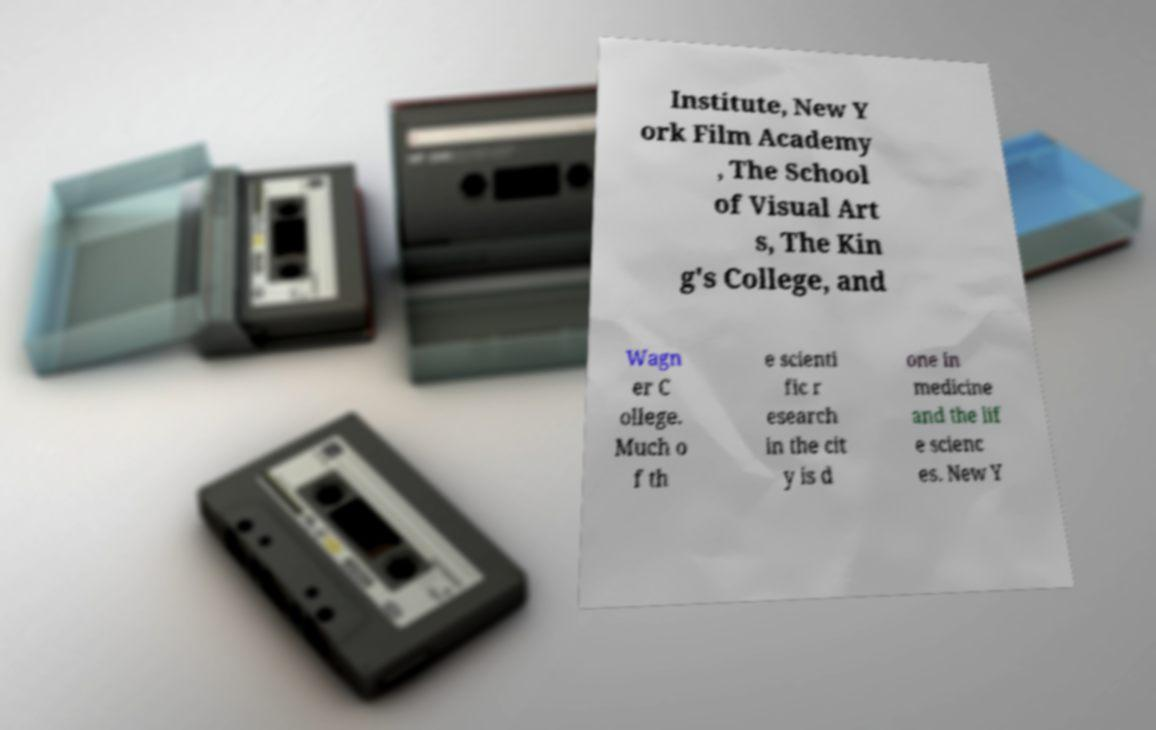I need the written content from this picture converted into text. Can you do that? Institute, New Y ork Film Academy , The School of Visual Art s, The Kin g's College, and Wagn er C ollege. Much o f th e scienti fic r esearch in the cit y is d one in medicine and the lif e scienc es. New Y 